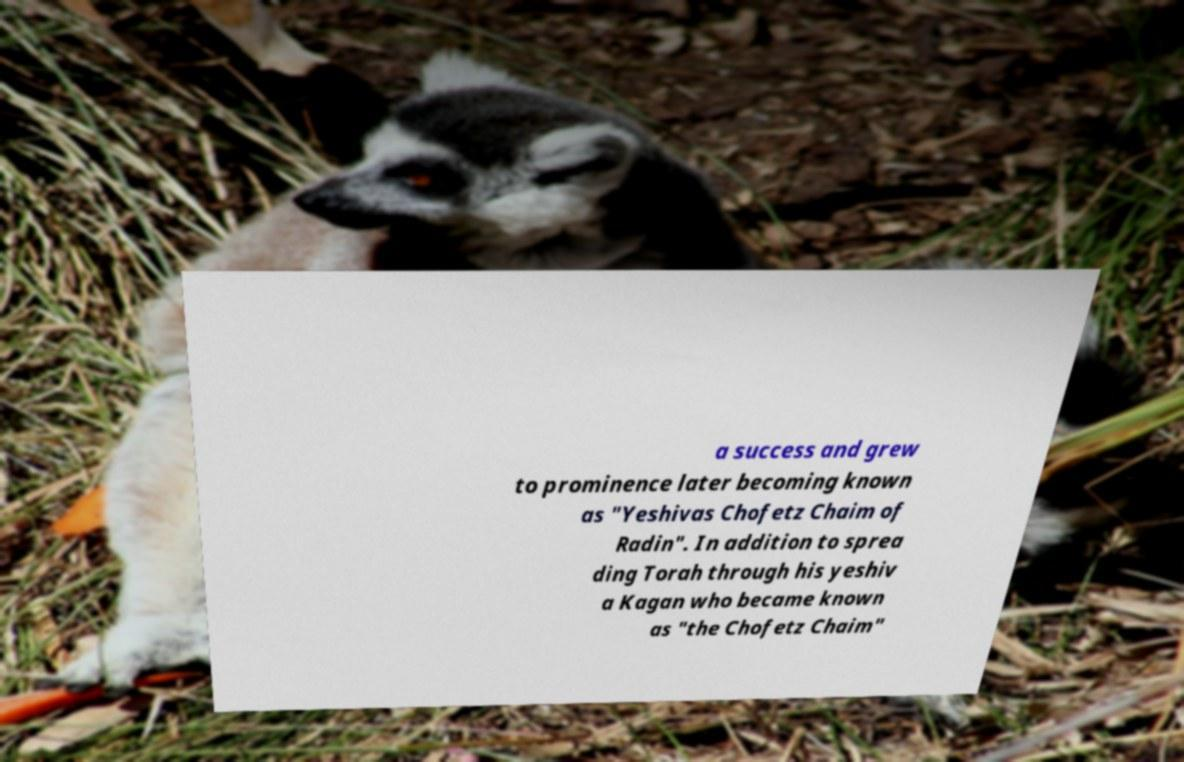What messages or text are displayed in this image? I need them in a readable, typed format. a success and grew to prominence later becoming known as "Yeshivas Chofetz Chaim of Radin". In addition to sprea ding Torah through his yeshiv a Kagan who became known as "the Chofetz Chaim" 